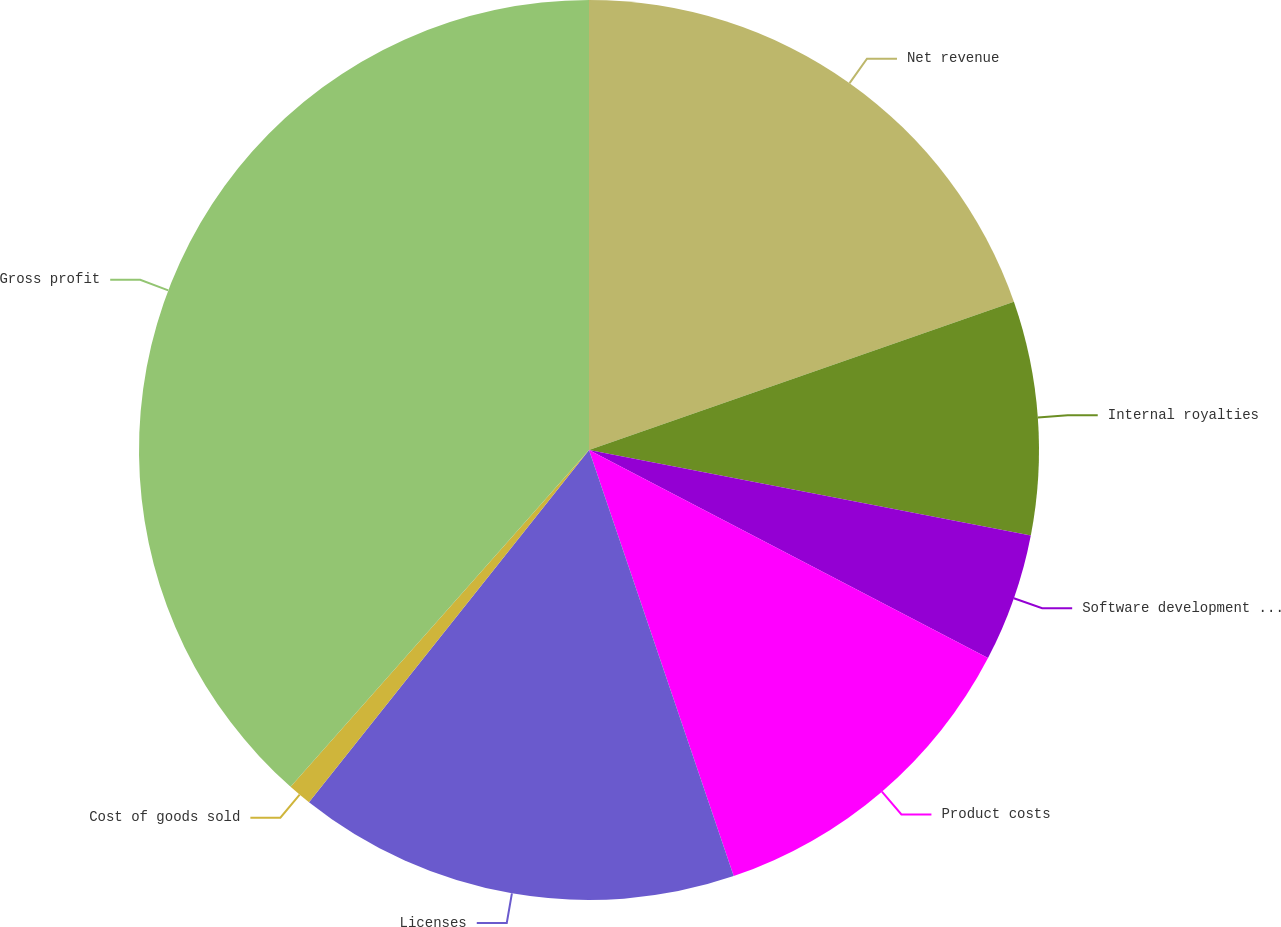Convert chart to OTSL. <chart><loc_0><loc_0><loc_500><loc_500><pie_chart><fcel>Net revenue<fcel>Internal royalties<fcel>Software development costs and<fcel>Product costs<fcel>Licenses<fcel>Cost of goods sold<fcel>Gross profit<nl><fcel>19.66%<fcel>8.38%<fcel>4.61%<fcel>12.14%<fcel>15.9%<fcel>0.85%<fcel>38.46%<nl></chart> 